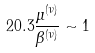Convert formula to latex. <formula><loc_0><loc_0><loc_500><loc_500>2 0 . 3 \frac { \mu ^ { ( \nu ) } } { \beta ^ { ( \nu ) } } \sim 1</formula> 